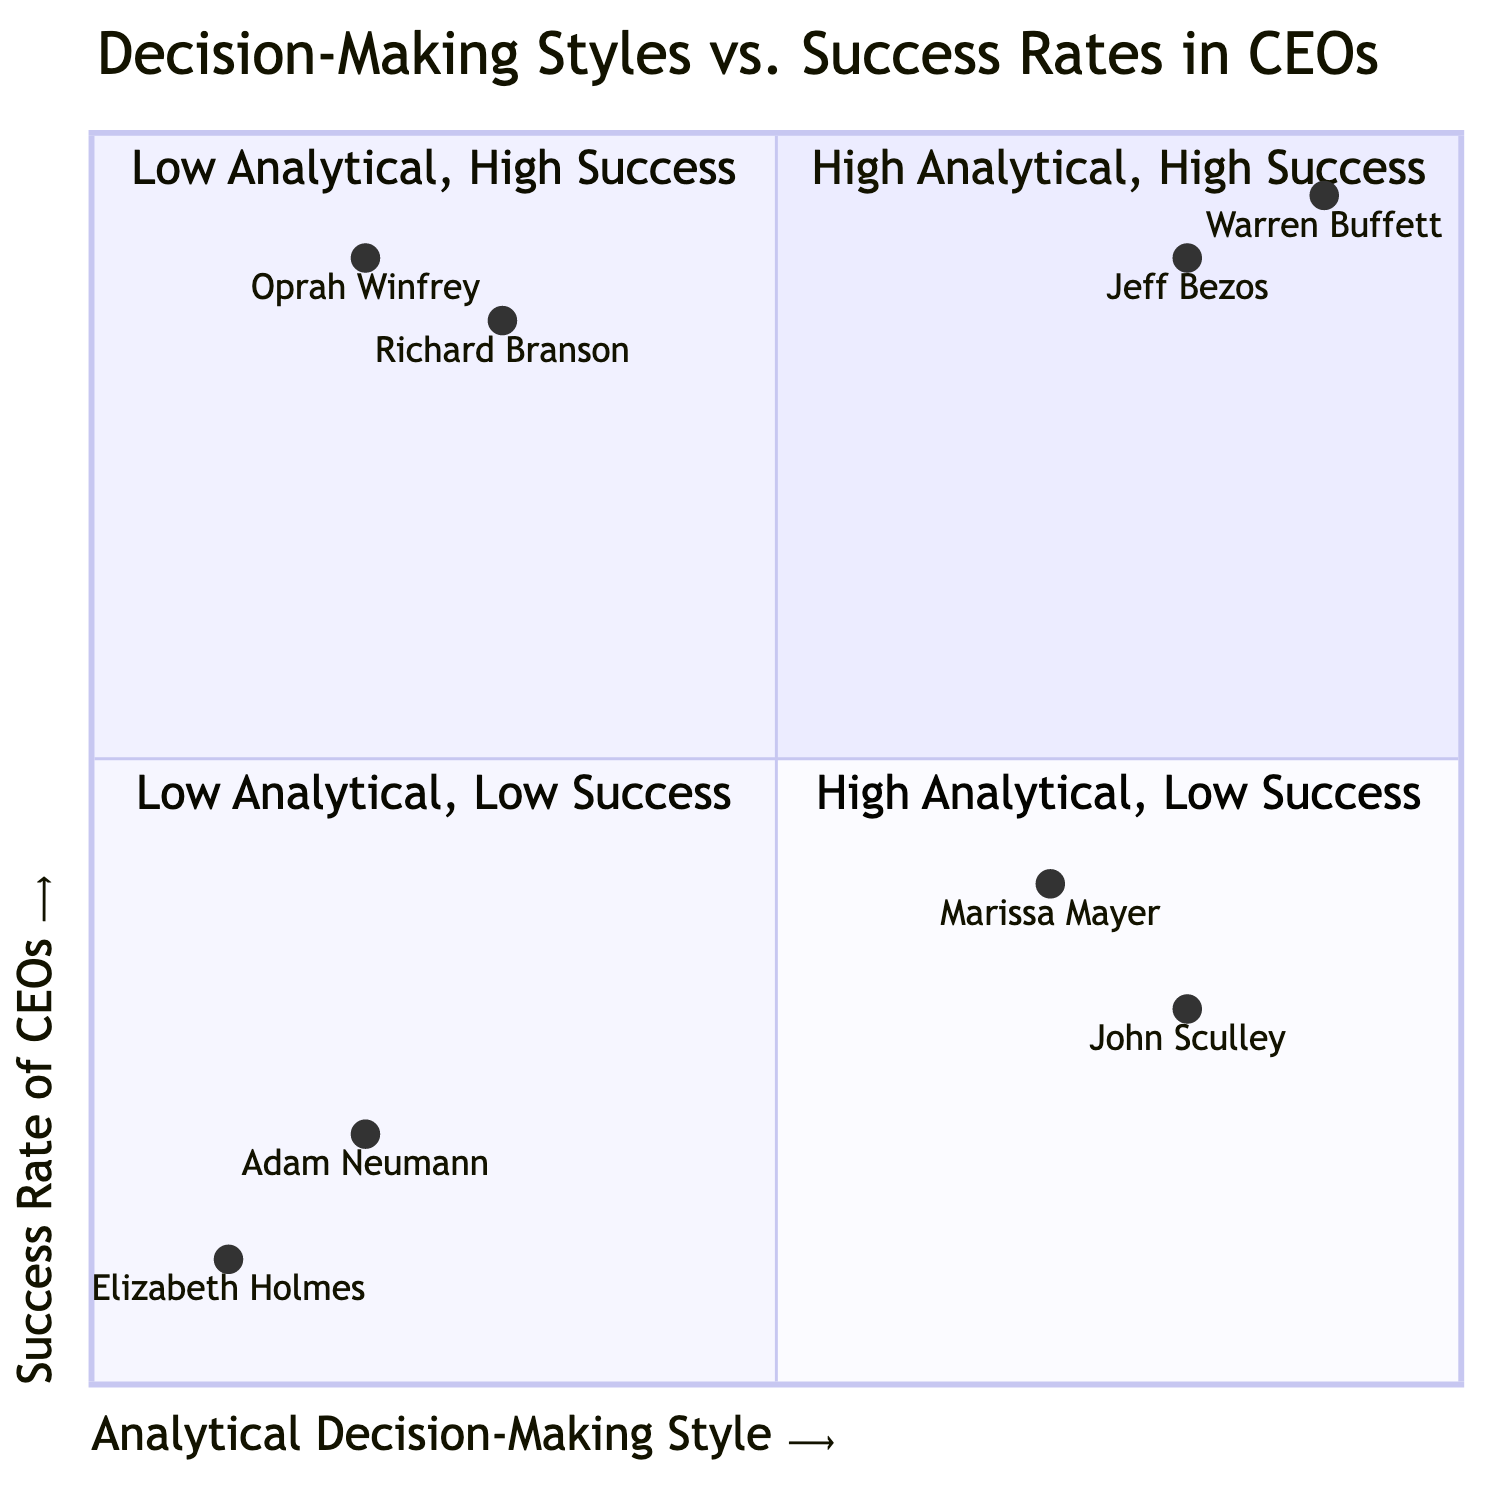What are the attributes of CEOs in the High Analytical, High Success quadrant? The High Analytical, High Success quadrant includes examples of Jeff Bezos and Warren Buffett. Their attributes are described as data-driven, having a long-term vision, and maintaining a high level of detail.
Answer: Data-driven, Long-term vision, High level of detail How many CEOs are represented in the Low Analytical, Low Success quadrant? The Low Analytical, Low Success quadrant contains two CEOs: Adam Neumann and Elizabeth Holmes. Therefore, the total number of CEOs in this quadrant is two.
Answer: 2 Which CEO has the highest success rate among those with a High Analytical decision-making style? In the High Analytical, High Success quadrant, Warren Buffett has the highest success rate, which is shown as 0.95.
Answer: Warren Buffett What is the relationship between analytical decision-making style and success rate for Oprah Winfrey? Oprah Winfrey, who has a Low Analytical decision-making style, is in the Low Analytical, High Success quadrant and has a success rate of 0.9. This indicates that a low analytical style can still lead to high success.
Answer: Low Analytical, High Success Which quadrant contains the least successful CEOs? The Low Analytical, Low Success quadrant contains the least successful CEOs, with both Adam Neumann and Elizabeth Holmes having low success rates of 0.2 and 0.1, respectively.
Answer: Low Analytical, Low Success What percentage of the CEOs in the High Analytical, Low Success quadrant have a success rate below 0.5? Both Marissa Mayer and John Sculley in the High Analytical, Low Success quadrant have success rates below 0.5 (0.4 and 0.3, respectively), indicating 100% of the CEOs in this quadrant fall below that threshold.
Answer: 100% How many quadrants are there in this diagram? The diagram features four distinct quadrants, each illustrating different combinations of decision-making styles and success rates.
Answer: 4 What is the success rate of Richard Branson? Richard Branson's success rate is shown in the Low Analytical, High Success quadrant as 0.85.
Answer: 0.85 